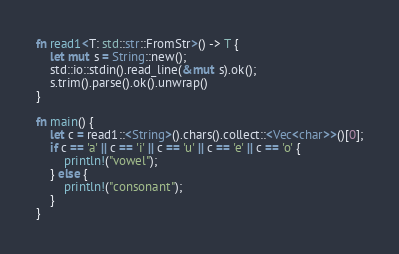Convert code to text. <code><loc_0><loc_0><loc_500><loc_500><_Rust_>fn read1<T: std::str::FromStr>() -> T {
    let mut s = String::new();
    std::io::stdin().read_line(&mut s).ok();
    s.trim().parse().ok().unwrap()
}

fn main() {
    let c = read1::<String>().chars().collect::<Vec<char>>()[0];
    if c == 'a' || c == 'i' || c == 'u' || c == 'e' || c == 'o' {
        println!("vowel");
    } else {
        println!("consonant");
    }
}</code> 